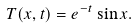Convert formula to latex. <formula><loc_0><loc_0><loc_500><loc_500>T ( x , t ) = e ^ { - t } \sin x .</formula> 